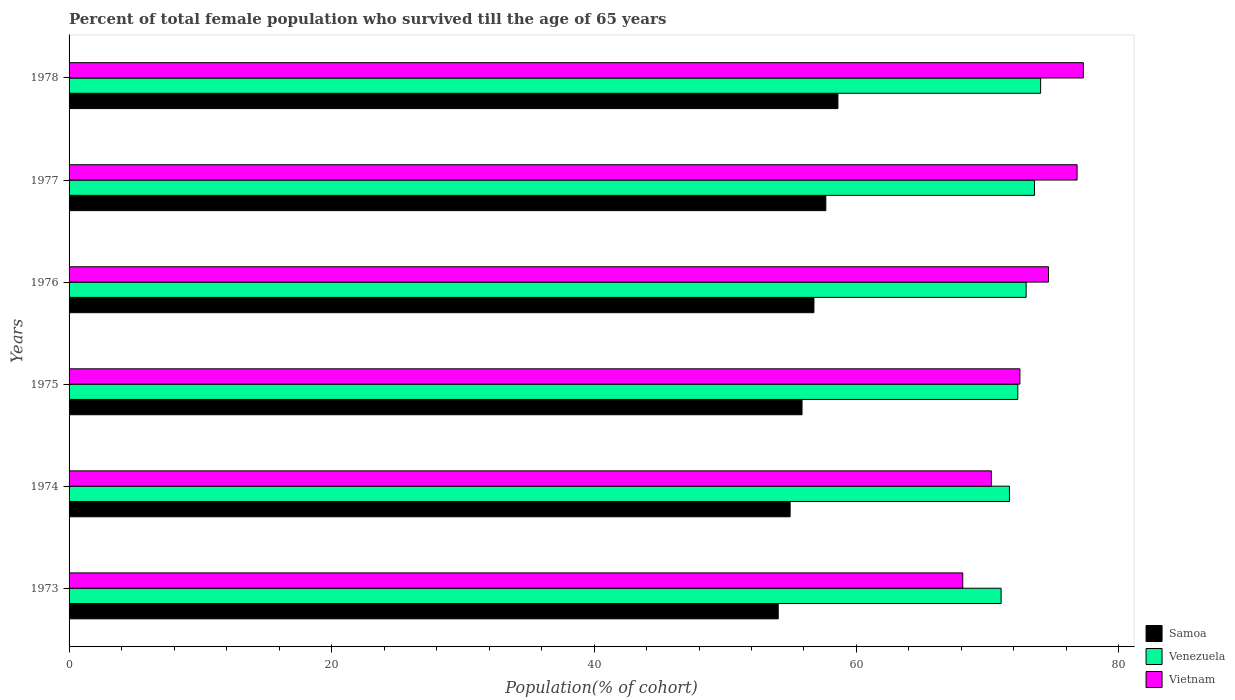Are the number of bars per tick equal to the number of legend labels?
Offer a very short reply. Yes. In how many cases, is the number of bars for a given year not equal to the number of legend labels?
Your answer should be compact. 0. What is the percentage of total female population who survived till the age of 65 years in Venezuela in 1974?
Provide a short and direct response. 71.66. Across all years, what is the maximum percentage of total female population who survived till the age of 65 years in Venezuela?
Your answer should be very brief. 74.03. Across all years, what is the minimum percentage of total female population who survived till the age of 65 years in Vietnam?
Your response must be concise. 68.1. In which year was the percentage of total female population who survived till the age of 65 years in Venezuela maximum?
Ensure brevity in your answer.  1978. In which year was the percentage of total female population who survived till the age of 65 years in Vietnam minimum?
Give a very brief answer. 1973. What is the total percentage of total female population who survived till the age of 65 years in Vietnam in the graph?
Give a very brief answer. 439.56. What is the difference between the percentage of total female population who survived till the age of 65 years in Samoa in 1973 and that in 1977?
Provide a short and direct response. -3.63. What is the difference between the percentage of total female population who survived till the age of 65 years in Venezuela in 1977 and the percentage of total female population who survived till the age of 65 years in Samoa in 1974?
Ensure brevity in your answer.  18.62. What is the average percentage of total female population who survived till the age of 65 years in Venezuela per year?
Your response must be concise. 72.58. In the year 1974, what is the difference between the percentage of total female population who survived till the age of 65 years in Venezuela and percentage of total female population who survived till the age of 65 years in Vietnam?
Keep it short and to the point. 1.38. What is the ratio of the percentage of total female population who survived till the age of 65 years in Vietnam in 1973 to that in 1976?
Your answer should be compact. 0.91. Is the percentage of total female population who survived till the age of 65 years in Vietnam in 1973 less than that in 1978?
Your answer should be compact. Yes. Is the difference between the percentage of total female population who survived till the age of 65 years in Venezuela in 1974 and 1978 greater than the difference between the percentage of total female population who survived till the age of 65 years in Vietnam in 1974 and 1978?
Offer a terse response. Yes. What is the difference between the highest and the second highest percentage of total female population who survived till the age of 65 years in Vietnam?
Offer a very short reply. 0.48. What is the difference between the highest and the lowest percentage of total female population who survived till the age of 65 years in Venezuela?
Provide a succinct answer. 3.01. In how many years, is the percentage of total female population who survived till the age of 65 years in Samoa greater than the average percentage of total female population who survived till the age of 65 years in Samoa taken over all years?
Ensure brevity in your answer.  3. Is the sum of the percentage of total female population who survived till the age of 65 years in Samoa in 1975 and 1976 greater than the maximum percentage of total female population who survived till the age of 65 years in Venezuela across all years?
Your answer should be compact. Yes. What does the 3rd bar from the top in 1974 represents?
Provide a succinct answer. Samoa. What does the 1st bar from the bottom in 1973 represents?
Your answer should be compact. Samoa. Are all the bars in the graph horizontal?
Provide a succinct answer. Yes. How many years are there in the graph?
Offer a terse response. 6. Are the values on the major ticks of X-axis written in scientific E-notation?
Offer a very short reply. No. Does the graph contain any zero values?
Give a very brief answer. No. Does the graph contain grids?
Offer a terse response. No. How many legend labels are there?
Provide a succinct answer. 3. What is the title of the graph?
Your answer should be very brief. Percent of total female population who survived till the age of 65 years. Does "Middle East & North Africa (developing only)" appear as one of the legend labels in the graph?
Give a very brief answer. No. What is the label or title of the X-axis?
Your response must be concise. Population(% of cohort). What is the Population(% of cohort) of Samoa in 1973?
Provide a short and direct response. 54.04. What is the Population(% of cohort) in Venezuela in 1973?
Your response must be concise. 71.02. What is the Population(% of cohort) of Vietnam in 1973?
Provide a short and direct response. 68.1. What is the Population(% of cohort) of Samoa in 1974?
Provide a short and direct response. 54.94. What is the Population(% of cohort) in Venezuela in 1974?
Ensure brevity in your answer.  71.66. What is the Population(% of cohort) in Vietnam in 1974?
Give a very brief answer. 70.28. What is the Population(% of cohort) of Samoa in 1975?
Offer a very short reply. 55.85. What is the Population(% of cohort) in Venezuela in 1975?
Make the answer very short. 72.29. What is the Population(% of cohort) of Vietnam in 1975?
Your answer should be compact. 72.45. What is the Population(% of cohort) of Samoa in 1976?
Make the answer very short. 56.76. What is the Population(% of cohort) in Venezuela in 1976?
Offer a very short reply. 72.93. What is the Population(% of cohort) of Vietnam in 1976?
Offer a terse response. 74.63. What is the Population(% of cohort) in Samoa in 1977?
Offer a terse response. 57.66. What is the Population(% of cohort) in Venezuela in 1977?
Keep it short and to the point. 73.56. What is the Population(% of cohort) of Vietnam in 1977?
Your answer should be very brief. 76.81. What is the Population(% of cohort) in Samoa in 1978?
Provide a succinct answer. 58.59. What is the Population(% of cohort) in Venezuela in 1978?
Make the answer very short. 74.03. What is the Population(% of cohort) in Vietnam in 1978?
Your answer should be compact. 77.29. Across all years, what is the maximum Population(% of cohort) in Samoa?
Keep it short and to the point. 58.59. Across all years, what is the maximum Population(% of cohort) in Venezuela?
Keep it short and to the point. 74.03. Across all years, what is the maximum Population(% of cohort) of Vietnam?
Your response must be concise. 77.29. Across all years, what is the minimum Population(% of cohort) in Samoa?
Provide a succinct answer. 54.04. Across all years, what is the minimum Population(% of cohort) in Venezuela?
Your answer should be compact. 71.02. Across all years, what is the minimum Population(% of cohort) in Vietnam?
Your answer should be very brief. 68.1. What is the total Population(% of cohort) in Samoa in the graph?
Provide a succinct answer. 337.84. What is the total Population(% of cohort) in Venezuela in the graph?
Keep it short and to the point. 435.49. What is the total Population(% of cohort) of Vietnam in the graph?
Give a very brief answer. 439.56. What is the difference between the Population(% of cohort) in Samoa in 1973 and that in 1974?
Provide a succinct answer. -0.91. What is the difference between the Population(% of cohort) in Venezuela in 1973 and that in 1974?
Keep it short and to the point. -0.64. What is the difference between the Population(% of cohort) in Vietnam in 1973 and that in 1974?
Give a very brief answer. -2.18. What is the difference between the Population(% of cohort) of Samoa in 1973 and that in 1975?
Ensure brevity in your answer.  -1.81. What is the difference between the Population(% of cohort) in Venezuela in 1973 and that in 1975?
Offer a very short reply. -1.27. What is the difference between the Population(% of cohort) of Vietnam in 1973 and that in 1975?
Provide a short and direct response. -4.36. What is the difference between the Population(% of cohort) of Samoa in 1973 and that in 1976?
Provide a succinct answer. -2.72. What is the difference between the Population(% of cohort) in Venezuela in 1973 and that in 1976?
Provide a succinct answer. -1.91. What is the difference between the Population(% of cohort) in Vietnam in 1973 and that in 1976?
Your answer should be compact. -6.53. What is the difference between the Population(% of cohort) in Samoa in 1973 and that in 1977?
Your response must be concise. -3.63. What is the difference between the Population(% of cohort) of Venezuela in 1973 and that in 1977?
Your answer should be very brief. -2.54. What is the difference between the Population(% of cohort) of Vietnam in 1973 and that in 1977?
Keep it short and to the point. -8.71. What is the difference between the Population(% of cohort) of Samoa in 1973 and that in 1978?
Provide a succinct answer. -4.55. What is the difference between the Population(% of cohort) of Venezuela in 1973 and that in 1978?
Your answer should be very brief. -3.01. What is the difference between the Population(% of cohort) of Vietnam in 1973 and that in 1978?
Ensure brevity in your answer.  -9.19. What is the difference between the Population(% of cohort) of Samoa in 1974 and that in 1975?
Offer a very short reply. -0.91. What is the difference between the Population(% of cohort) in Venezuela in 1974 and that in 1975?
Make the answer very short. -0.64. What is the difference between the Population(% of cohort) of Vietnam in 1974 and that in 1975?
Your answer should be compact. -2.18. What is the difference between the Population(% of cohort) of Samoa in 1974 and that in 1976?
Your answer should be compact. -1.81. What is the difference between the Population(% of cohort) in Venezuela in 1974 and that in 1976?
Make the answer very short. -1.27. What is the difference between the Population(% of cohort) in Vietnam in 1974 and that in 1976?
Keep it short and to the point. -4.36. What is the difference between the Population(% of cohort) of Samoa in 1974 and that in 1977?
Make the answer very short. -2.72. What is the difference between the Population(% of cohort) in Venezuela in 1974 and that in 1977?
Offer a terse response. -1.91. What is the difference between the Population(% of cohort) in Vietnam in 1974 and that in 1977?
Offer a very short reply. -6.53. What is the difference between the Population(% of cohort) in Samoa in 1974 and that in 1978?
Provide a short and direct response. -3.64. What is the difference between the Population(% of cohort) of Venezuela in 1974 and that in 1978?
Make the answer very short. -2.37. What is the difference between the Population(% of cohort) in Vietnam in 1974 and that in 1978?
Provide a succinct answer. -7.01. What is the difference between the Population(% of cohort) of Samoa in 1975 and that in 1976?
Provide a succinct answer. -0.91. What is the difference between the Population(% of cohort) in Venezuela in 1975 and that in 1976?
Your response must be concise. -0.64. What is the difference between the Population(% of cohort) in Vietnam in 1975 and that in 1976?
Make the answer very short. -2.18. What is the difference between the Population(% of cohort) in Samoa in 1975 and that in 1977?
Your answer should be compact. -1.81. What is the difference between the Population(% of cohort) in Venezuela in 1975 and that in 1977?
Offer a very short reply. -1.27. What is the difference between the Population(% of cohort) of Vietnam in 1975 and that in 1977?
Make the answer very short. -4.36. What is the difference between the Population(% of cohort) of Samoa in 1975 and that in 1978?
Make the answer very short. -2.73. What is the difference between the Population(% of cohort) in Venezuela in 1975 and that in 1978?
Offer a terse response. -1.74. What is the difference between the Population(% of cohort) in Vietnam in 1975 and that in 1978?
Your answer should be compact. -4.83. What is the difference between the Population(% of cohort) of Samoa in 1976 and that in 1977?
Keep it short and to the point. -0.91. What is the difference between the Population(% of cohort) of Venezuela in 1976 and that in 1977?
Your response must be concise. -0.64. What is the difference between the Population(% of cohort) in Vietnam in 1976 and that in 1977?
Your response must be concise. -2.18. What is the difference between the Population(% of cohort) in Samoa in 1976 and that in 1978?
Your response must be concise. -1.83. What is the difference between the Population(% of cohort) in Venezuela in 1976 and that in 1978?
Provide a succinct answer. -1.1. What is the difference between the Population(% of cohort) in Vietnam in 1976 and that in 1978?
Your answer should be compact. -2.65. What is the difference between the Population(% of cohort) of Samoa in 1977 and that in 1978?
Provide a succinct answer. -0.92. What is the difference between the Population(% of cohort) of Venezuela in 1977 and that in 1978?
Your answer should be compact. -0.47. What is the difference between the Population(% of cohort) in Vietnam in 1977 and that in 1978?
Your response must be concise. -0.48. What is the difference between the Population(% of cohort) of Samoa in 1973 and the Population(% of cohort) of Venezuela in 1974?
Keep it short and to the point. -17.62. What is the difference between the Population(% of cohort) of Samoa in 1973 and the Population(% of cohort) of Vietnam in 1974?
Make the answer very short. -16.24. What is the difference between the Population(% of cohort) in Venezuela in 1973 and the Population(% of cohort) in Vietnam in 1974?
Ensure brevity in your answer.  0.74. What is the difference between the Population(% of cohort) of Samoa in 1973 and the Population(% of cohort) of Venezuela in 1975?
Your answer should be compact. -18.26. What is the difference between the Population(% of cohort) in Samoa in 1973 and the Population(% of cohort) in Vietnam in 1975?
Your answer should be compact. -18.42. What is the difference between the Population(% of cohort) in Venezuela in 1973 and the Population(% of cohort) in Vietnam in 1975?
Your answer should be very brief. -1.43. What is the difference between the Population(% of cohort) of Samoa in 1973 and the Population(% of cohort) of Venezuela in 1976?
Ensure brevity in your answer.  -18.89. What is the difference between the Population(% of cohort) of Samoa in 1973 and the Population(% of cohort) of Vietnam in 1976?
Offer a terse response. -20.6. What is the difference between the Population(% of cohort) of Venezuela in 1973 and the Population(% of cohort) of Vietnam in 1976?
Offer a very short reply. -3.61. What is the difference between the Population(% of cohort) in Samoa in 1973 and the Population(% of cohort) in Venezuela in 1977?
Keep it short and to the point. -19.53. What is the difference between the Population(% of cohort) of Samoa in 1973 and the Population(% of cohort) of Vietnam in 1977?
Provide a succinct answer. -22.77. What is the difference between the Population(% of cohort) in Venezuela in 1973 and the Population(% of cohort) in Vietnam in 1977?
Your answer should be compact. -5.79. What is the difference between the Population(% of cohort) in Samoa in 1973 and the Population(% of cohort) in Venezuela in 1978?
Make the answer very short. -19.99. What is the difference between the Population(% of cohort) of Samoa in 1973 and the Population(% of cohort) of Vietnam in 1978?
Keep it short and to the point. -23.25. What is the difference between the Population(% of cohort) in Venezuela in 1973 and the Population(% of cohort) in Vietnam in 1978?
Give a very brief answer. -6.27. What is the difference between the Population(% of cohort) in Samoa in 1974 and the Population(% of cohort) in Venezuela in 1975?
Offer a terse response. -17.35. What is the difference between the Population(% of cohort) in Samoa in 1974 and the Population(% of cohort) in Vietnam in 1975?
Your answer should be very brief. -17.51. What is the difference between the Population(% of cohort) in Venezuela in 1974 and the Population(% of cohort) in Vietnam in 1975?
Give a very brief answer. -0.8. What is the difference between the Population(% of cohort) in Samoa in 1974 and the Population(% of cohort) in Venezuela in 1976?
Offer a very short reply. -17.99. What is the difference between the Population(% of cohort) of Samoa in 1974 and the Population(% of cohort) of Vietnam in 1976?
Make the answer very short. -19.69. What is the difference between the Population(% of cohort) in Venezuela in 1974 and the Population(% of cohort) in Vietnam in 1976?
Ensure brevity in your answer.  -2.98. What is the difference between the Population(% of cohort) of Samoa in 1974 and the Population(% of cohort) of Venezuela in 1977?
Provide a succinct answer. -18.62. What is the difference between the Population(% of cohort) of Samoa in 1974 and the Population(% of cohort) of Vietnam in 1977?
Keep it short and to the point. -21.87. What is the difference between the Population(% of cohort) of Venezuela in 1974 and the Population(% of cohort) of Vietnam in 1977?
Keep it short and to the point. -5.15. What is the difference between the Population(% of cohort) of Samoa in 1974 and the Population(% of cohort) of Venezuela in 1978?
Provide a succinct answer. -19.09. What is the difference between the Population(% of cohort) in Samoa in 1974 and the Population(% of cohort) in Vietnam in 1978?
Give a very brief answer. -22.34. What is the difference between the Population(% of cohort) in Venezuela in 1974 and the Population(% of cohort) in Vietnam in 1978?
Your response must be concise. -5.63. What is the difference between the Population(% of cohort) of Samoa in 1975 and the Population(% of cohort) of Venezuela in 1976?
Provide a succinct answer. -17.08. What is the difference between the Population(% of cohort) of Samoa in 1975 and the Population(% of cohort) of Vietnam in 1976?
Provide a succinct answer. -18.78. What is the difference between the Population(% of cohort) in Venezuela in 1975 and the Population(% of cohort) in Vietnam in 1976?
Offer a very short reply. -2.34. What is the difference between the Population(% of cohort) of Samoa in 1975 and the Population(% of cohort) of Venezuela in 1977?
Give a very brief answer. -17.71. What is the difference between the Population(% of cohort) in Samoa in 1975 and the Population(% of cohort) in Vietnam in 1977?
Offer a terse response. -20.96. What is the difference between the Population(% of cohort) of Venezuela in 1975 and the Population(% of cohort) of Vietnam in 1977?
Keep it short and to the point. -4.52. What is the difference between the Population(% of cohort) in Samoa in 1975 and the Population(% of cohort) in Venezuela in 1978?
Keep it short and to the point. -18.18. What is the difference between the Population(% of cohort) in Samoa in 1975 and the Population(% of cohort) in Vietnam in 1978?
Give a very brief answer. -21.44. What is the difference between the Population(% of cohort) of Venezuela in 1975 and the Population(% of cohort) of Vietnam in 1978?
Ensure brevity in your answer.  -4.99. What is the difference between the Population(% of cohort) in Samoa in 1976 and the Population(% of cohort) in Venezuela in 1977?
Your answer should be very brief. -16.81. What is the difference between the Population(% of cohort) of Samoa in 1976 and the Population(% of cohort) of Vietnam in 1977?
Give a very brief answer. -20.05. What is the difference between the Population(% of cohort) of Venezuela in 1976 and the Population(% of cohort) of Vietnam in 1977?
Give a very brief answer. -3.88. What is the difference between the Population(% of cohort) in Samoa in 1976 and the Population(% of cohort) in Venezuela in 1978?
Your response must be concise. -17.27. What is the difference between the Population(% of cohort) in Samoa in 1976 and the Population(% of cohort) in Vietnam in 1978?
Ensure brevity in your answer.  -20.53. What is the difference between the Population(% of cohort) in Venezuela in 1976 and the Population(% of cohort) in Vietnam in 1978?
Offer a very short reply. -4.36. What is the difference between the Population(% of cohort) in Samoa in 1977 and the Population(% of cohort) in Venezuela in 1978?
Ensure brevity in your answer.  -16.37. What is the difference between the Population(% of cohort) in Samoa in 1977 and the Population(% of cohort) in Vietnam in 1978?
Provide a short and direct response. -19.62. What is the difference between the Population(% of cohort) of Venezuela in 1977 and the Population(% of cohort) of Vietnam in 1978?
Offer a terse response. -3.72. What is the average Population(% of cohort) in Samoa per year?
Offer a very short reply. 56.31. What is the average Population(% of cohort) in Venezuela per year?
Ensure brevity in your answer.  72.58. What is the average Population(% of cohort) in Vietnam per year?
Your answer should be compact. 73.26. In the year 1973, what is the difference between the Population(% of cohort) in Samoa and Population(% of cohort) in Venezuela?
Provide a succinct answer. -16.98. In the year 1973, what is the difference between the Population(% of cohort) of Samoa and Population(% of cohort) of Vietnam?
Make the answer very short. -14.06. In the year 1973, what is the difference between the Population(% of cohort) of Venezuela and Population(% of cohort) of Vietnam?
Offer a very short reply. 2.92. In the year 1974, what is the difference between the Population(% of cohort) of Samoa and Population(% of cohort) of Venezuela?
Your answer should be very brief. -16.71. In the year 1974, what is the difference between the Population(% of cohort) in Samoa and Population(% of cohort) in Vietnam?
Offer a very short reply. -15.33. In the year 1974, what is the difference between the Population(% of cohort) in Venezuela and Population(% of cohort) in Vietnam?
Make the answer very short. 1.38. In the year 1975, what is the difference between the Population(% of cohort) in Samoa and Population(% of cohort) in Venezuela?
Your response must be concise. -16.44. In the year 1975, what is the difference between the Population(% of cohort) in Samoa and Population(% of cohort) in Vietnam?
Ensure brevity in your answer.  -16.6. In the year 1975, what is the difference between the Population(% of cohort) in Venezuela and Population(% of cohort) in Vietnam?
Give a very brief answer. -0.16. In the year 1976, what is the difference between the Population(% of cohort) in Samoa and Population(% of cohort) in Venezuela?
Provide a succinct answer. -16.17. In the year 1976, what is the difference between the Population(% of cohort) in Samoa and Population(% of cohort) in Vietnam?
Offer a very short reply. -17.87. In the year 1976, what is the difference between the Population(% of cohort) of Venezuela and Population(% of cohort) of Vietnam?
Your answer should be compact. -1.7. In the year 1977, what is the difference between the Population(% of cohort) in Samoa and Population(% of cohort) in Venezuela?
Provide a short and direct response. -15.9. In the year 1977, what is the difference between the Population(% of cohort) of Samoa and Population(% of cohort) of Vietnam?
Offer a very short reply. -19.15. In the year 1977, what is the difference between the Population(% of cohort) of Venezuela and Population(% of cohort) of Vietnam?
Offer a terse response. -3.25. In the year 1978, what is the difference between the Population(% of cohort) of Samoa and Population(% of cohort) of Venezuela?
Ensure brevity in your answer.  -15.44. In the year 1978, what is the difference between the Population(% of cohort) in Samoa and Population(% of cohort) in Vietnam?
Provide a succinct answer. -18.7. In the year 1978, what is the difference between the Population(% of cohort) of Venezuela and Population(% of cohort) of Vietnam?
Provide a succinct answer. -3.26. What is the ratio of the Population(% of cohort) of Samoa in 1973 to that in 1974?
Provide a succinct answer. 0.98. What is the ratio of the Population(% of cohort) in Venezuela in 1973 to that in 1974?
Your answer should be compact. 0.99. What is the ratio of the Population(% of cohort) of Samoa in 1973 to that in 1975?
Give a very brief answer. 0.97. What is the ratio of the Population(% of cohort) in Venezuela in 1973 to that in 1975?
Offer a very short reply. 0.98. What is the ratio of the Population(% of cohort) in Vietnam in 1973 to that in 1975?
Ensure brevity in your answer.  0.94. What is the ratio of the Population(% of cohort) of Venezuela in 1973 to that in 1976?
Provide a succinct answer. 0.97. What is the ratio of the Population(% of cohort) of Vietnam in 1973 to that in 1976?
Offer a terse response. 0.91. What is the ratio of the Population(% of cohort) in Samoa in 1973 to that in 1977?
Offer a terse response. 0.94. What is the ratio of the Population(% of cohort) in Venezuela in 1973 to that in 1977?
Provide a succinct answer. 0.97. What is the ratio of the Population(% of cohort) of Vietnam in 1973 to that in 1977?
Provide a succinct answer. 0.89. What is the ratio of the Population(% of cohort) of Samoa in 1973 to that in 1978?
Make the answer very short. 0.92. What is the ratio of the Population(% of cohort) of Venezuela in 1973 to that in 1978?
Provide a short and direct response. 0.96. What is the ratio of the Population(% of cohort) in Vietnam in 1973 to that in 1978?
Your answer should be compact. 0.88. What is the ratio of the Population(% of cohort) of Samoa in 1974 to that in 1975?
Your answer should be compact. 0.98. What is the ratio of the Population(% of cohort) in Vietnam in 1974 to that in 1975?
Your answer should be very brief. 0.97. What is the ratio of the Population(% of cohort) of Samoa in 1974 to that in 1976?
Your answer should be compact. 0.97. What is the ratio of the Population(% of cohort) of Venezuela in 1974 to that in 1976?
Ensure brevity in your answer.  0.98. What is the ratio of the Population(% of cohort) in Vietnam in 1974 to that in 1976?
Your response must be concise. 0.94. What is the ratio of the Population(% of cohort) in Samoa in 1974 to that in 1977?
Make the answer very short. 0.95. What is the ratio of the Population(% of cohort) in Venezuela in 1974 to that in 1977?
Your answer should be very brief. 0.97. What is the ratio of the Population(% of cohort) of Vietnam in 1974 to that in 1977?
Offer a very short reply. 0.91. What is the ratio of the Population(% of cohort) of Samoa in 1974 to that in 1978?
Provide a succinct answer. 0.94. What is the ratio of the Population(% of cohort) in Venezuela in 1974 to that in 1978?
Offer a terse response. 0.97. What is the ratio of the Population(% of cohort) in Vietnam in 1974 to that in 1978?
Give a very brief answer. 0.91. What is the ratio of the Population(% of cohort) in Vietnam in 1975 to that in 1976?
Keep it short and to the point. 0.97. What is the ratio of the Population(% of cohort) in Samoa in 1975 to that in 1977?
Keep it short and to the point. 0.97. What is the ratio of the Population(% of cohort) in Venezuela in 1975 to that in 1977?
Provide a short and direct response. 0.98. What is the ratio of the Population(% of cohort) in Vietnam in 1975 to that in 1977?
Your answer should be very brief. 0.94. What is the ratio of the Population(% of cohort) of Samoa in 1975 to that in 1978?
Your answer should be very brief. 0.95. What is the ratio of the Population(% of cohort) of Venezuela in 1975 to that in 1978?
Give a very brief answer. 0.98. What is the ratio of the Population(% of cohort) of Samoa in 1976 to that in 1977?
Offer a very short reply. 0.98. What is the ratio of the Population(% of cohort) of Venezuela in 1976 to that in 1977?
Offer a very short reply. 0.99. What is the ratio of the Population(% of cohort) in Vietnam in 1976 to that in 1977?
Offer a very short reply. 0.97. What is the ratio of the Population(% of cohort) of Samoa in 1976 to that in 1978?
Provide a short and direct response. 0.97. What is the ratio of the Population(% of cohort) in Venezuela in 1976 to that in 1978?
Your answer should be very brief. 0.99. What is the ratio of the Population(% of cohort) in Vietnam in 1976 to that in 1978?
Make the answer very short. 0.97. What is the ratio of the Population(% of cohort) in Samoa in 1977 to that in 1978?
Ensure brevity in your answer.  0.98. What is the difference between the highest and the second highest Population(% of cohort) in Samoa?
Ensure brevity in your answer.  0.92. What is the difference between the highest and the second highest Population(% of cohort) in Venezuela?
Your answer should be compact. 0.47. What is the difference between the highest and the second highest Population(% of cohort) in Vietnam?
Ensure brevity in your answer.  0.48. What is the difference between the highest and the lowest Population(% of cohort) of Samoa?
Provide a short and direct response. 4.55. What is the difference between the highest and the lowest Population(% of cohort) in Venezuela?
Ensure brevity in your answer.  3.01. What is the difference between the highest and the lowest Population(% of cohort) in Vietnam?
Offer a terse response. 9.19. 